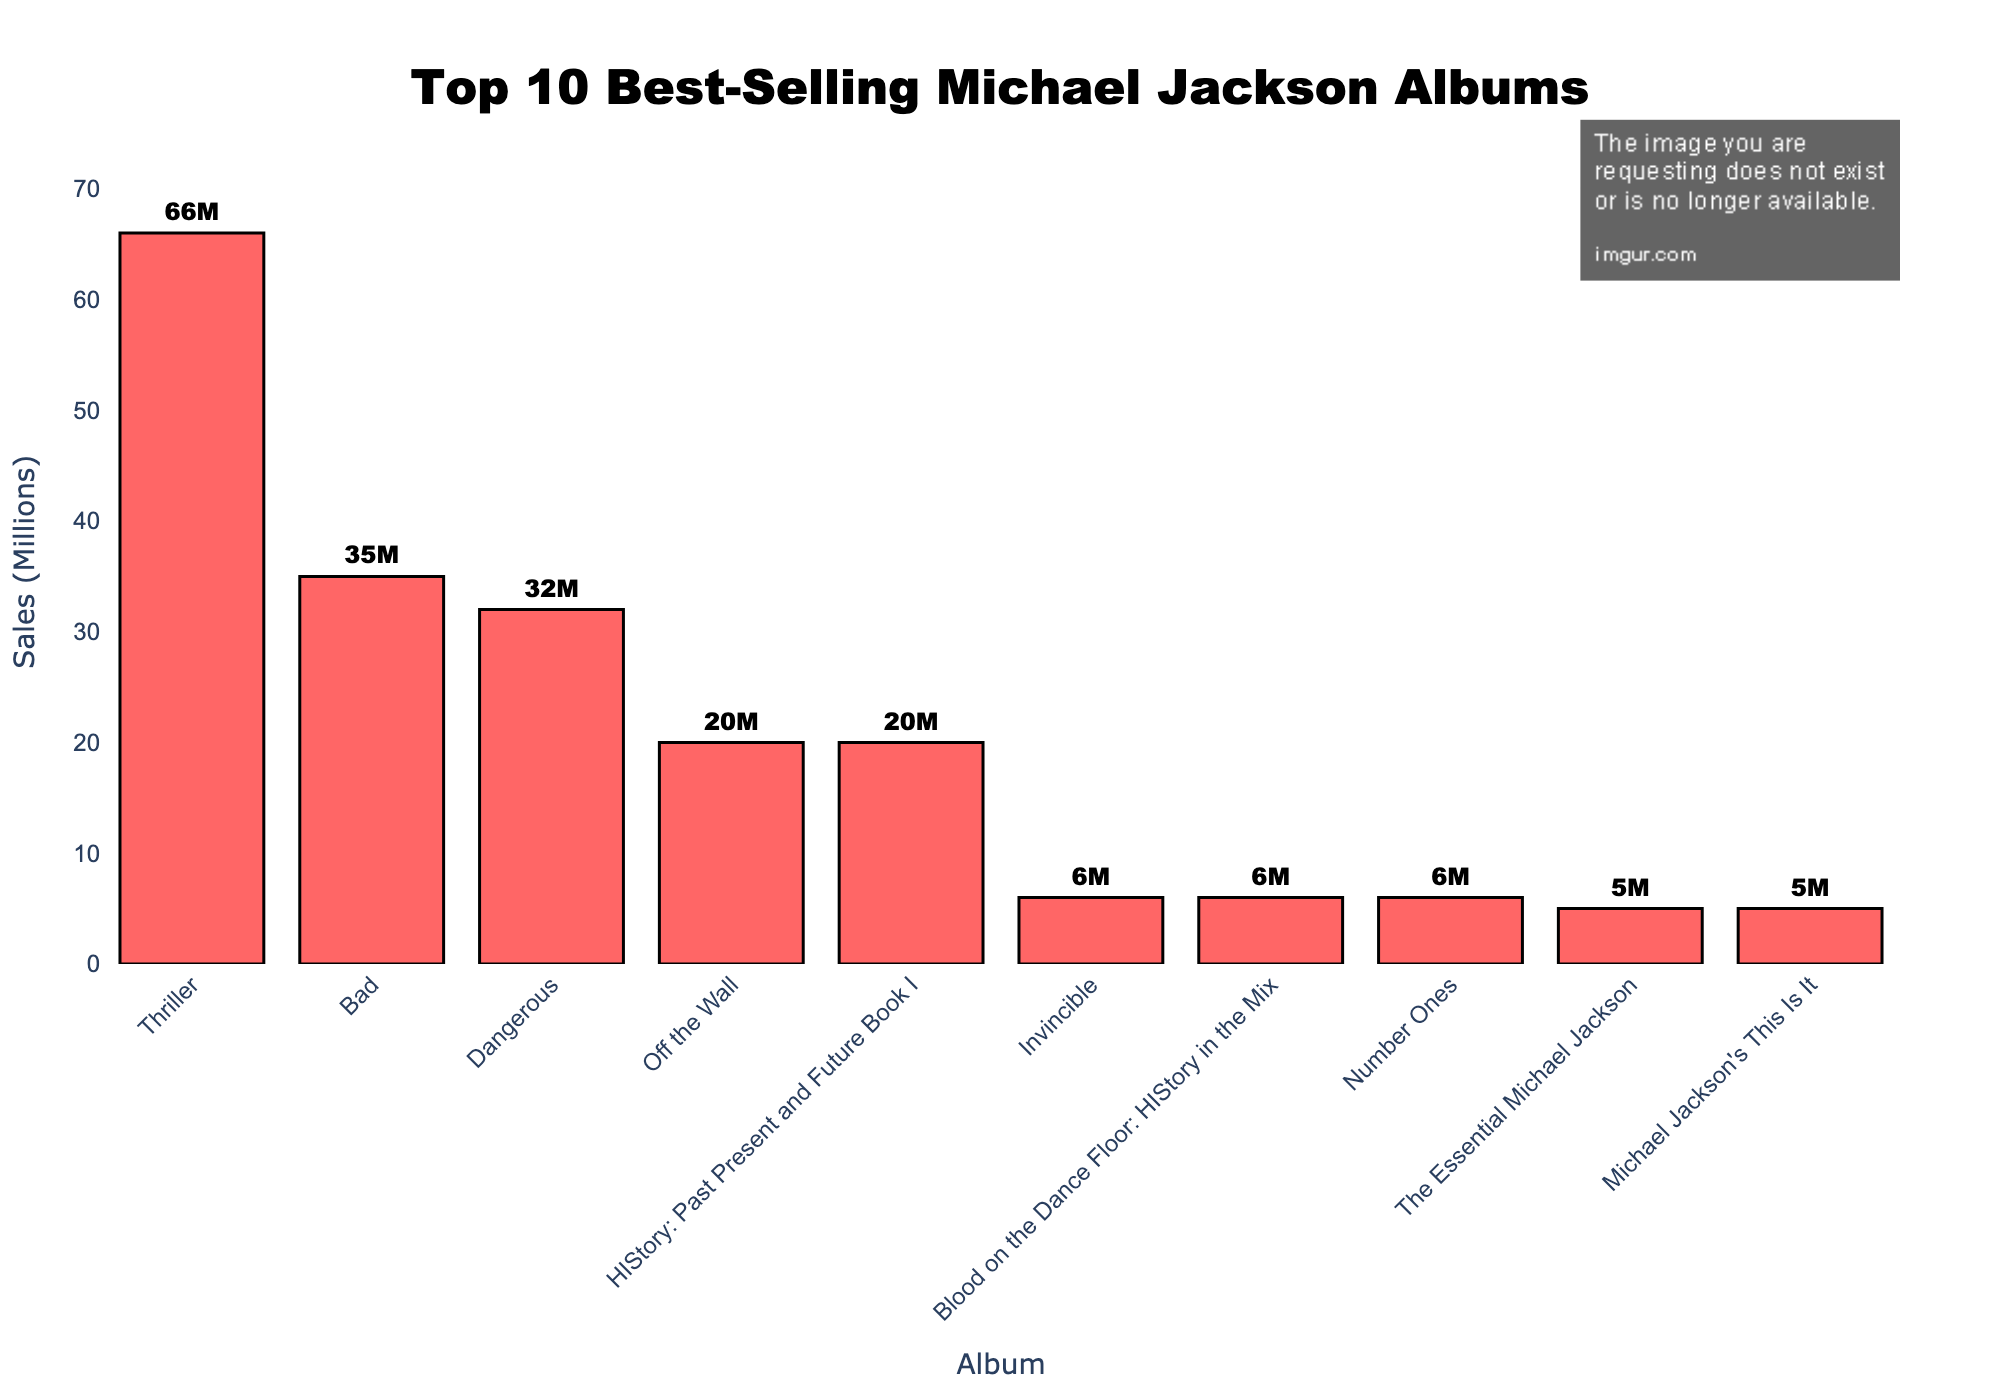What is the best-selling Michael Jackson album? The best-selling album is determined by the highest bar in the chart, which is "Thriller" with 66 million sales.
Answer: Thriller Which album sold more, "Bad" or "Dangerous"? To compare, look at the height of the bars for "Bad" (35 million) and "Dangerous" (32 million). "Bad" is higher, indicating it sold more.
Answer: Bad What is the combined sales of the albums "HIStory: Past Present and Future Book I", "Invincible", and "Blood on the Dance Floor: HIStory in the Mix"? Sum the sales of the three albums: 20 (HIStory) + 6 (Invincible) + 6 (Blood on the Dance Floor) = 32 million.
Answer: 32 million How many albums have sales figures of 20 million? Count the number of bars at the 20 million mark: "Off the Wall" and "HIStory: Past Present and Future Book I" both have 20 million sales.
Answer: 2 albums Which album has the lowest sales figures? The bar with the lowest height corresponds to the "Michael Jackson's This Is It" and "The Essential Michael Jackson" albums, both with 5 million sales.
Answer: Michael Jackson's This Is It, The Essential Michael Jackson What is the average sales figure of all the albums? To find the average, sum all the sales figures and divide by the number of albums: (66 + 35 + 32 + 20 + 20 + 6 + 6 + 6 + 5 + 5) / 10 = 201 / 10 = 20.1 million.
Answer: 20.1 million Among "Invincible", "Number Ones", and "Michael Jackson's This Is It", which has the highest sales? Compare the heights of bars: "Invincible" and "Number Ones" both have 6 million sales, higher than "Michael Jackson's This Is It" with 5 million.
Answer: Invincible, Number Ones How much more did "Thriller" sell compared to "Bad"? Subtract the sales of "Bad" from "Thriller": 66 million - 35 million = 31 million.
Answer: 31 million Are there any albums with exactly half the sales of "Bad"? Calculate half of "Bad" which is 35 million / 2 = 17.5 million and check the bars. No album has exactly 17.5 million sales.
Answer: No Which albums have sales figures shown in red bars? All bars representing sales figures in the chart are colored red, so all albums listed are shown in red bars.
Answer: All albums 